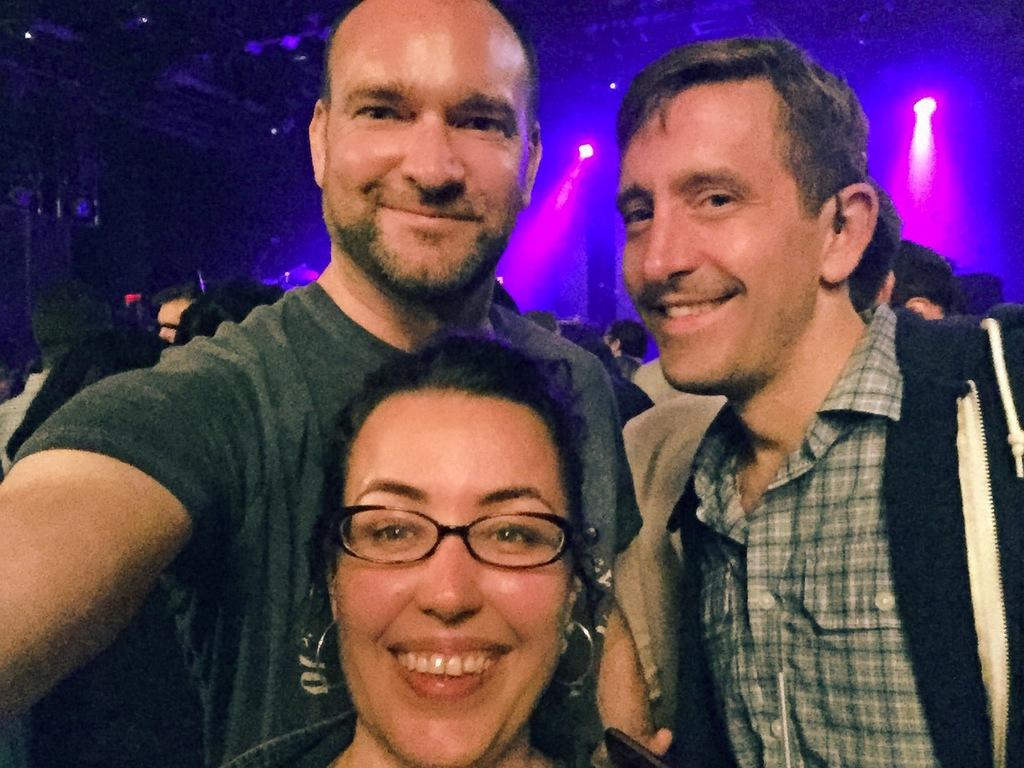Who or what can be seen in the image? There are people in the image. What can be seen illuminating the scene? There are lights visible in the image. What type of structure is present in the image? There is a shed in the image. Where are the objects located in the image? The objects are on the left side of the image. What is the value of the cub in the image? There is no cub present in the image, so it is not possible to determine its value. 